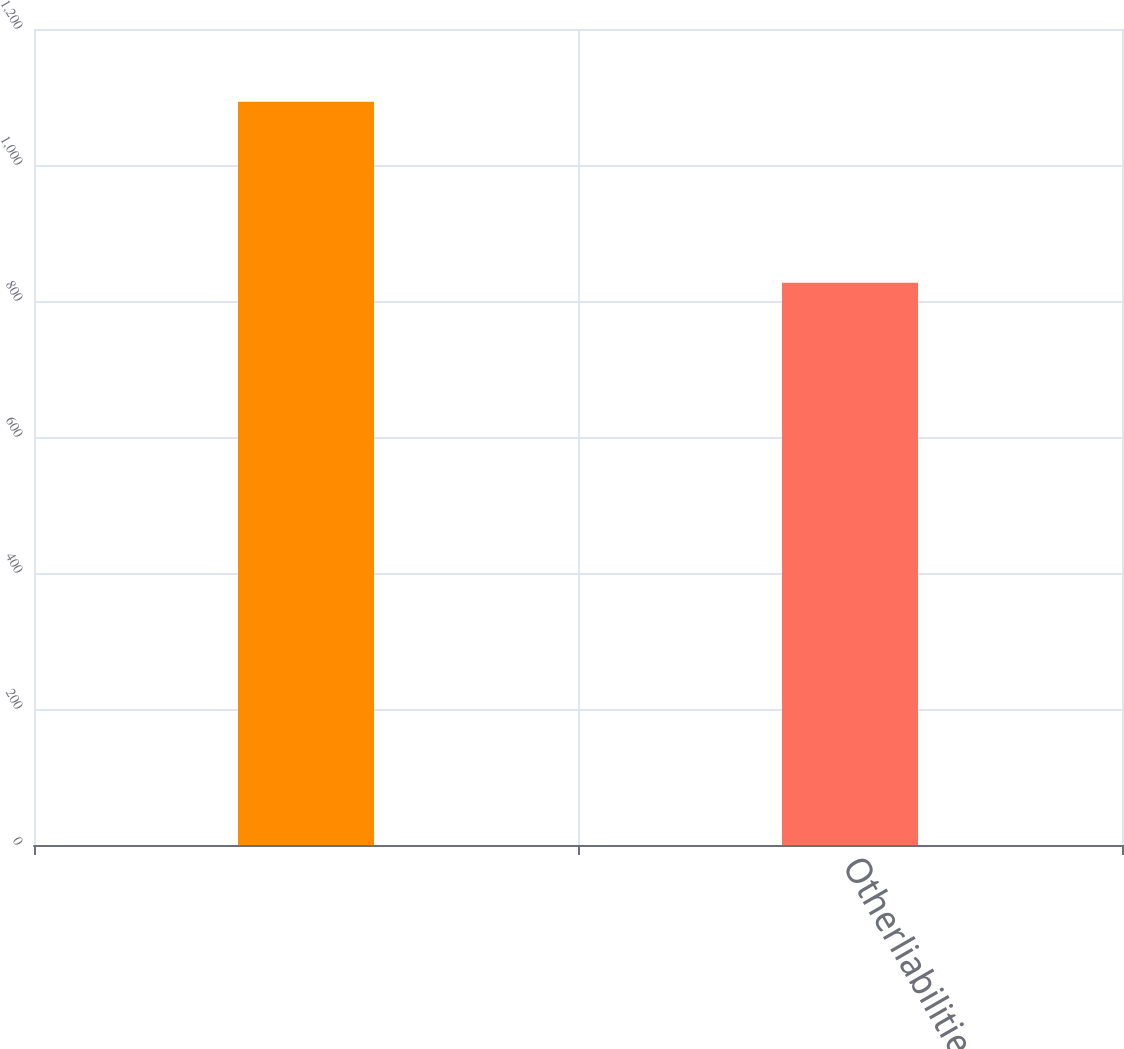Convert chart to OTSL. <chart><loc_0><loc_0><loc_500><loc_500><bar_chart><ecel><fcel>Otherliabilities<nl><fcel>1093<fcel>827<nl></chart> 